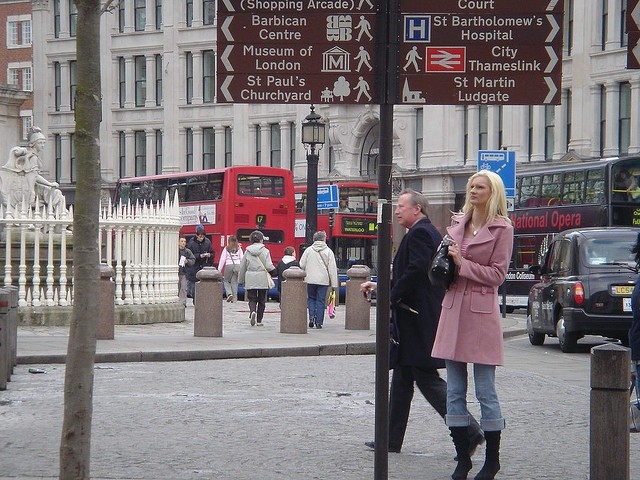Describe the objects in this image and their specific colors. I can see people in gray, darkgray, and black tones, bus in gray, black, darkgray, and maroon tones, car in gray, black, and darkgray tones, people in gray, black, and darkgray tones, and bus in gray, brown, and black tones in this image. 